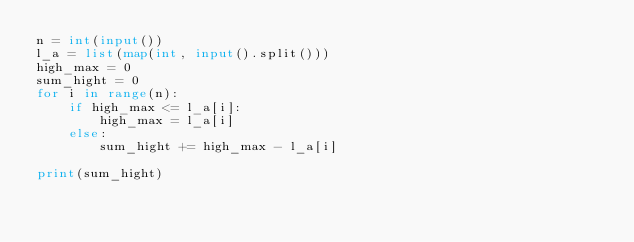Convert code to text. <code><loc_0><loc_0><loc_500><loc_500><_Python_>n = int(input())
l_a = list(map(int, input().split()))
high_max = 0
sum_hight = 0
for i in range(n):
    if high_max <= l_a[i]:
        high_max = l_a[i]
    else:
        sum_hight += high_max - l_a[i]

print(sum_hight)</code> 